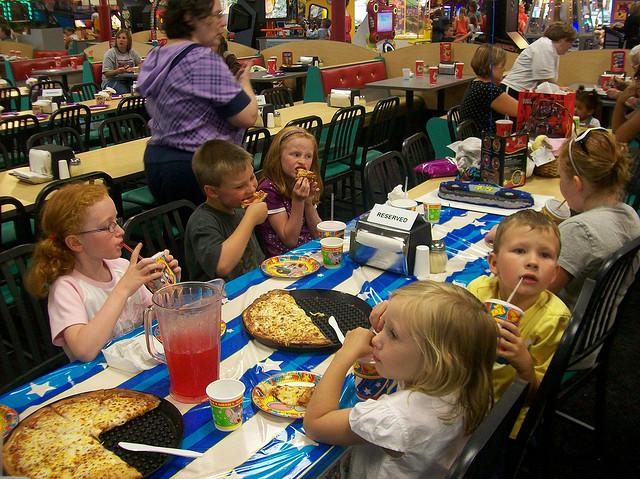Are they sitting on folding chairs?
Give a very brief answer. No. How many slices of pizza are left on the pizza to the far left?
Concise answer only. 6. How many kids are on the photo?
Answer briefly. 6. Do the children have drinks?
Quick response, please. Yes. 